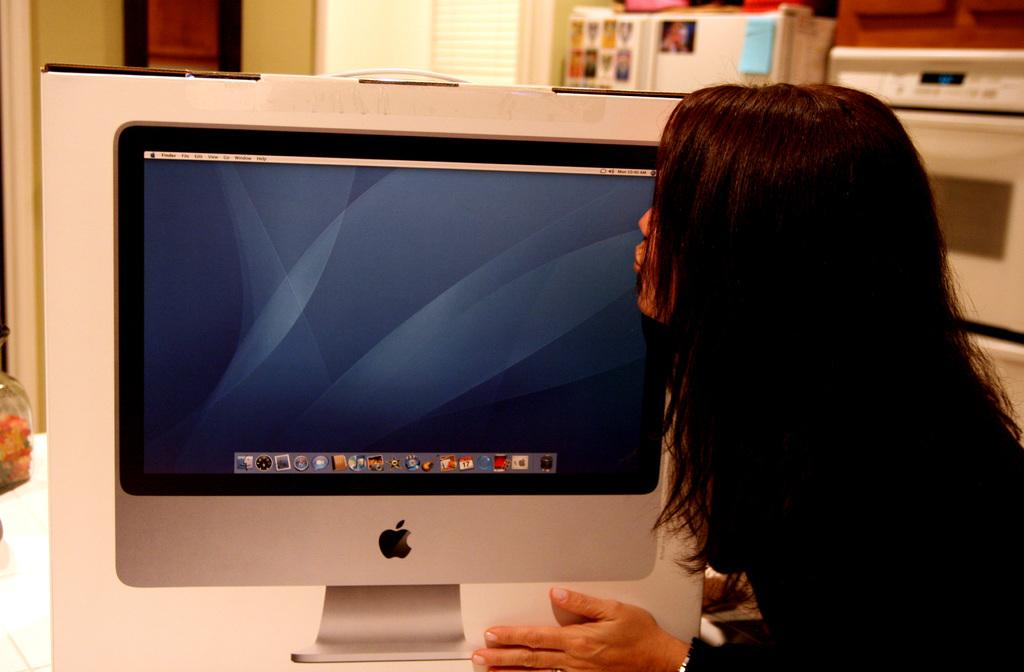Who is in the image? There is a woman in the image. What object can be seen in the image? There is a box in the image. What is on the box? The box has a system image on it. What can be seen in the background of the image? There are images and electronic devices present in the background of the image. Where is the grandmother in the wilderness in the image? There is no grandmother or wilderness present in the image. What type of ball can be seen in the image? There is no ball present in the image. 